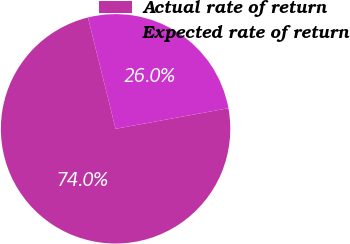<chart> <loc_0><loc_0><loc_500><loc_500><pie_chart><fcel>Actual rate of return<fcel>Expected rate of return<nl><fcel>74.0%<fcel>26.0%<nl></chart> 